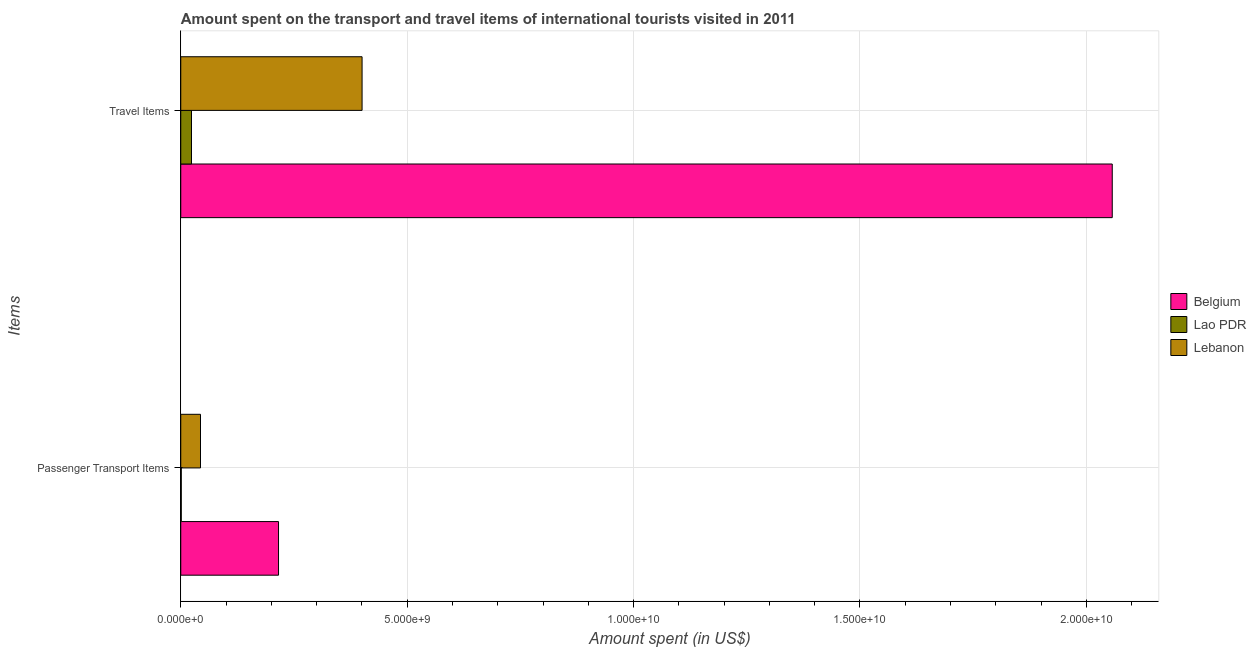How many bars are there on the 1st tick from the bottom?
Your answer should be compact. 3. What is the label of the 1st group of bars from the top?
Provide a short and direct response. Travel Items. What is the amount spent in travel items in Lebanon?
Your answer should be very brief. 4.00e+09. Across all countries, what is the maximum amount spent in travel items?
Your answer should be very brief. 2.06e+1. Across all countries, what is the minimum amount spent in travel items?
Provide a succinct answer. 2.37e+08. In which country was the amount spent on passenger transport items maximum?
Make the answer very short. Belgium. In which country was the amount spent in travel items minimum?
Provide a short and direct response. Lao PDR. What is the total amount spent on passenger transport items in the graph?
Provide a short and direct response. 2.61e+09. What is the difference between the amount spent in travel items in Belgium and that in Lao PDR?
Ensure brevity in your answer.  2.03e+1. What is the difference between the amount spent in travel items in Lebanon and the amount spent on passenger transport items in Lao PDR?
Keep it short and to the point. 3.99e+09. What is the average amount spent on passenger transport items per country?
Make the answer very short. 8.69e+08. What is the difference between the amount spent in travel items and amount spent on passenger transport items in Lebanon?
Provide a succinct answer. 3.57e+09. In how many countries, is the amount spent in travel items greater than 6000000000 US$?
Offer a terse response. 1. What is the ratio of the amount spent in travel items in Belgium to that in Lebanon?
Make the answer very short. 5.14. Is the amount spent in travel items in Lao PDR less than that in Lebanon?
Give a very brief answer. Yes. What does the 2nd bar from the top in Passenger Transport Items represents?
Keep it short and to the point. Lao PDR. What does the 3rd bar from the bottom in Passenger Transport Items represents?
Offer a terse response. Lebanon. Does the graph contain grids?
Your response must be concise. Yes. Where does the legend appear in the graph?
Provide a short and direct response. Center right. What is the title of the graph?
Your response must be concise. Amount spent on the transport and travel items of international tourists visited in 2011. Does "Mauritius" appear as one of the legend labels in the graph?
Provide a short and direct response. No. What is the label or title of the X-axis?
Your response must be concise. Amount spent (in US$). What is the label or title of the Y-axis?
Provide a succinct answer. Items. What is the Amount spent (in US$) of Belgium in Passenger Transport Items?
Give a very brief answer. 2.16e+09. What is the Amount spent (in US$) of Lao PDR in Passenger Transport Items?
Your answer should be very brief. 1.10e+07. What is the Amount spent (in US$) in Lebanon in Passenger Transport Items?
Your response must be concise. 4.36e+08. What is the Amount spent (in US$) in Belgium in Travel Items?
Your answer should be very brief. 2.06e+1. What is the Amount spent (in US$) of Lao PDR in Travel Items?
Give a very brief answer. 2.37e+08. What is the Amount spent (in US$) of Lebanon in Travel Items?
Your answer should be compact. 4.00e+09. Across all Items, what is the maximum Amount spent (in US$) in Belgium?
Make the answer very short. 2.06e+1. Across all Items, what is the maximum Amount spent (in US$) in Lao PDR?
Offer a very short reply. 2.37e+08. Across all Items, what is the maximum Amount spent (in US$) of Lebanon?
Make the answer very short. 4.00e+09. Across all Items, what is the minimum Amount spent (in US$) in Belgium?
Offer a very short reply. 2.16e+09. Across all Items, what is the minimum Amount spent (in US$) in Lao PDR?
Provide a succinct answer. 1.10e+07. Across all Items, what is the minimum Amount spent (in US$) in Lebanon?
Provide a short and direct response. 4.36e+08. What is the total Amount spent (in US$) in Belgium in the graph?
Ensure brevity in your answer.  2.27e+1. What is the total Amount spent (in US$) of Lao PDR in the graph?
Keep it short and to the point. 2.48e+08. What is the total Amount spent (in US$) in Lebanon in the graph?
Provide a short and direct response. 4.44e+09. What is the difference between the Amount spent (in US$) in Belgium in Passenger Transport Items and that in Travel Items?
Ensure brevity in your answer.  -1.84e+1. What is the difference between the Amount spent (in US$) of Lao PDR in Passenger Transport Items and that in Travel Items?
Give a very brief answer. -2.26e+08. What is the difference between the Amount spent (in US$) of Lebanon in Passenger Transport Items and that in Travel Items?
Offer a very short reply. -3.57e+09. What is the difference between the Amount spent (in US$) of Belgium in Passenger Transport Items and the Amount spent (in US$) of Lao PDR in Travel Items?
Provide a short and direct response. 1.92e+09. What is the difference between the Amount spent (in US$) of Belgium in Passenger Transport Items and the Amount spent (in US$) of Lebanon in Travel Items?
Make the answer very short. -1.84e+09. What is the difference between the Amount spent (in US$) of Lao PDR in Passenger Transport Items and the Amount spent (in US$) of Lebanon in Travel Items?
Your response must be concise. -3.99e+09. What is the average Amount spent (in US$) of Belgium per Items?
Give a very brief answer. 1.14e+1. What is the average Amount spent (in US$) of Lao PDR per Items?
Your response must be concise. 1.24e+08. What is the average Amount spent (in US$) in Lebanon per Items?
Ensure brevity in your answer.  2.22e+09. What is the difference between the Amount spent (in US$) of Belgium and Amount spent (in US$) of Lao PDR in Passenger Transport Items?
Provide a succinct answer. 2.15e+09. What is the difference between the Amount spent (in US$) in Belgium and Amount spent (in US$) in Lebanon in Passenger Transport Items?
Provide a succinct answer. 1.72e+09. What is the difference between the Amount spent (in US$) of Lao PDR and Amount spent (in US$) of Lebanon in Passenger Transport Items?
Your answer should be compact. -4.25e+08. What is the difference between the Amount spent (in US$) of Belgium and Amount spent (in US$) of Lao PDR in Travel Items?
Make the answer very short. 2.03e+1. What is the difference between the Amount spent (in US$) of Belgium and Amount spent (in US$) of Lebanon in Travel Items?
Give a very brief answer. 1.66e+1. What is the difference between the Amount spent (in US$) of Lao PDR and Amount spent (in US$) of Lebanon in Travel Items?
Keep it short and to the point. -3.77e+09. What is the ratio of the Amount spent (in US$) in Belgium in Passenger Transport Items to that in Travel Items?
Ensure brevity in your answer.  0.1. What is the ratio of the Amount spent (in US$) of Lao PDR in Passenger Transport Items to that in Travel Items?
Keep it short and to the point. 0.05. What is the ratio of the Amount spent (in US$) of Lebanon in Passenger Transport Items to that in Travel Items?
Make the answer very short. 0.11. What is the difference between the highest and the second highest Amount spent (in US$) of Belgium?
Make the answer very short. 1.84e+1. What is the difference between the highest and the second highest Amount spent (in US$) of Lao PDR?
Provide a short and direct response. 2.26e+08. What is the difference between the highest and the second highest Amount spent (in US$) of Lebanon?
Keep it short and to the point. 3.57e+09. What is the difference between the highest and the lowest Amount spent (in US$) of Belgium?
Give a very brief answer. 1.84e+1. What is the difference between the highest and the lowest Amount spent (in US$) of Lao PDR?
Offer a terse response. 2.26e+08. What is the difference between the highest and the lowest Amount spent (in US$) in Lebanon?
Give a very brief answer. 3.57e+09. 